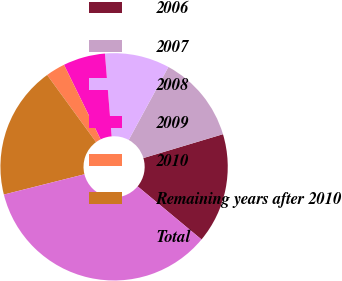Convert chart. <chart><loc_0><loc_0><loc_500><loc_500><pie_chart><fcel>2006<fcel>2007<fcel>2008<fcel>2009<fcel>2010<fcel>Remaining years after 2010<fcel>Total<nl><fcel>15.67%<fcel>12.44%<fcel>9.21%<fcel>5.98%<fcel>2.76%<fcel>18.9%<fcel>35.04%<nl></chart> 